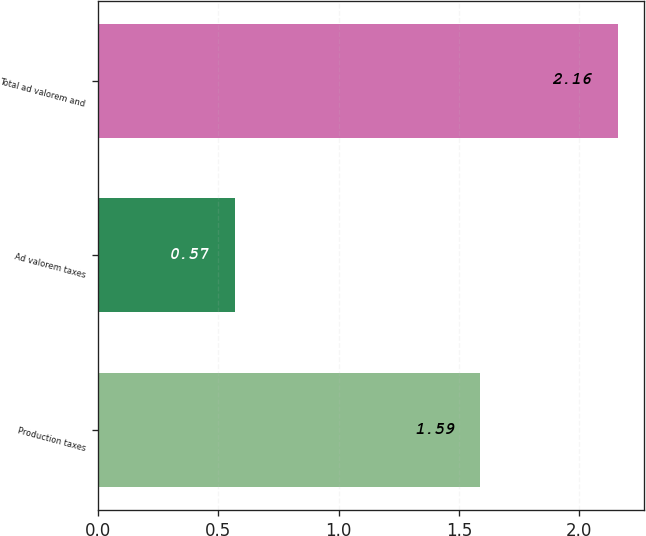<chart> <loc_0><loc_0><loc_500><loc_500><bar_chart><fcel>Production taxes<fcel>Ad valorem taxes<fcel>Total ad valorem and<nl><fcel>1.59<fcel>0.57<fcel>2.16<nl></chart> 